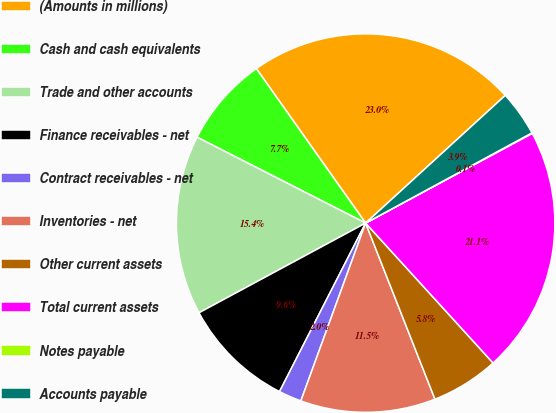Convert chart to OTSL. <chart><loc_0><loc_0><loc_500><loc_500><pie_chart><fcel>(Amounts in millions)<fcel>Cash and cash equivalents<fcel>Trade and other accounts<fcel>Finance receivables - net<fcel>Contract receivables - net<fcel>Inventories - net<fcel>Other current assets<fcel>Total current assets<fcel>Notes payable<fcel>Accounts payable<nl><fcel>23.01%<fcel>7.7%<fcel>15.36%<fcel>9.62%<fcel>1.96%<fcel>11.53%<fcel>5.79%<fcel>21.1%<fcel>0.05%<fcel>3.88%<nl></chart> 